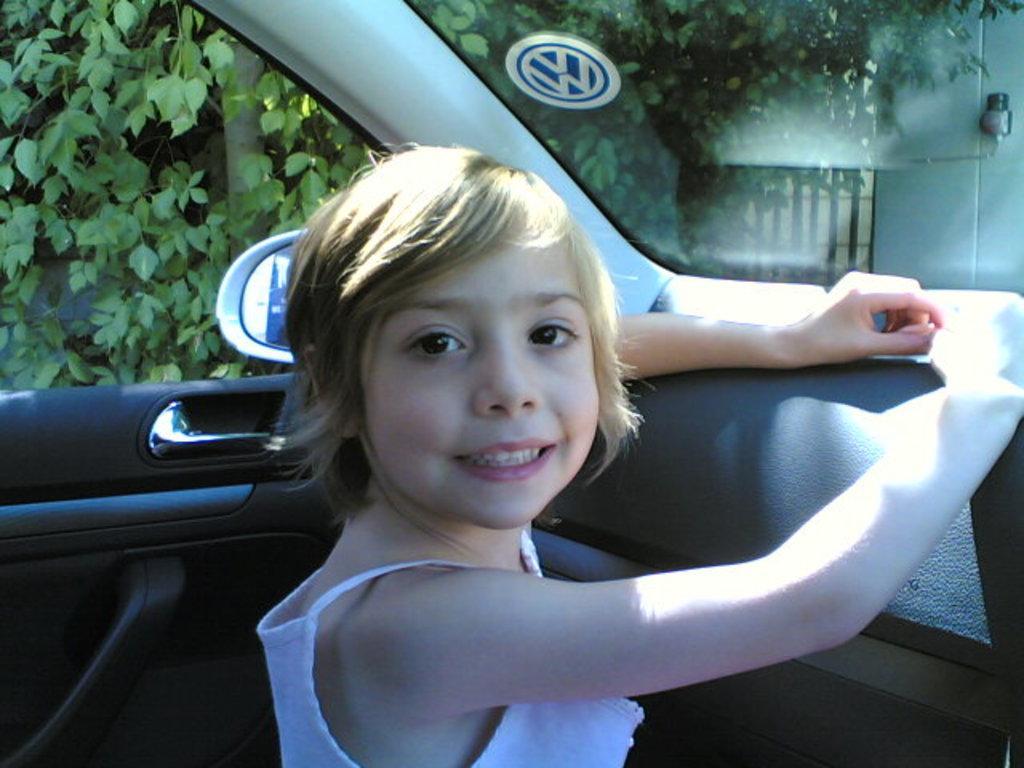Describe this image in one or two sentences. In this image I can see a person is inside the car. In the background there are trees and the building. 